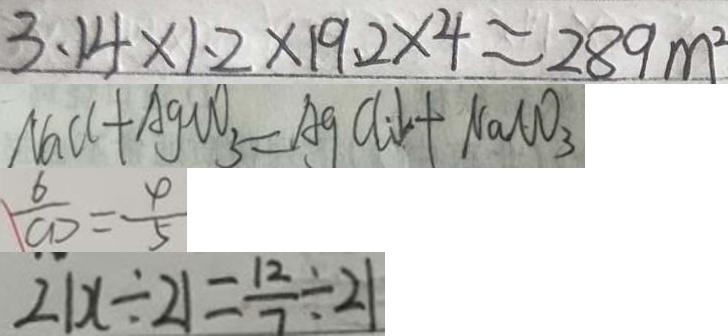<formula> <loc_0><loc_0><loc_500><loc_500>3 . 1 4 \times 1 . 2 \times 1 9 . 2 \times 4 \approx 2 8 9 m ^ { 2 } 
 N a C l + A g C O _ { 3 } = A g C l \downarrow + N a C O _ { 3 } 
 \frac { 6 } { C D } = \frac { 4 } { 5 } 
 2 1 x \div 2 1 = \frac { 1 2 } { 7 } \div 2 1</formula> 